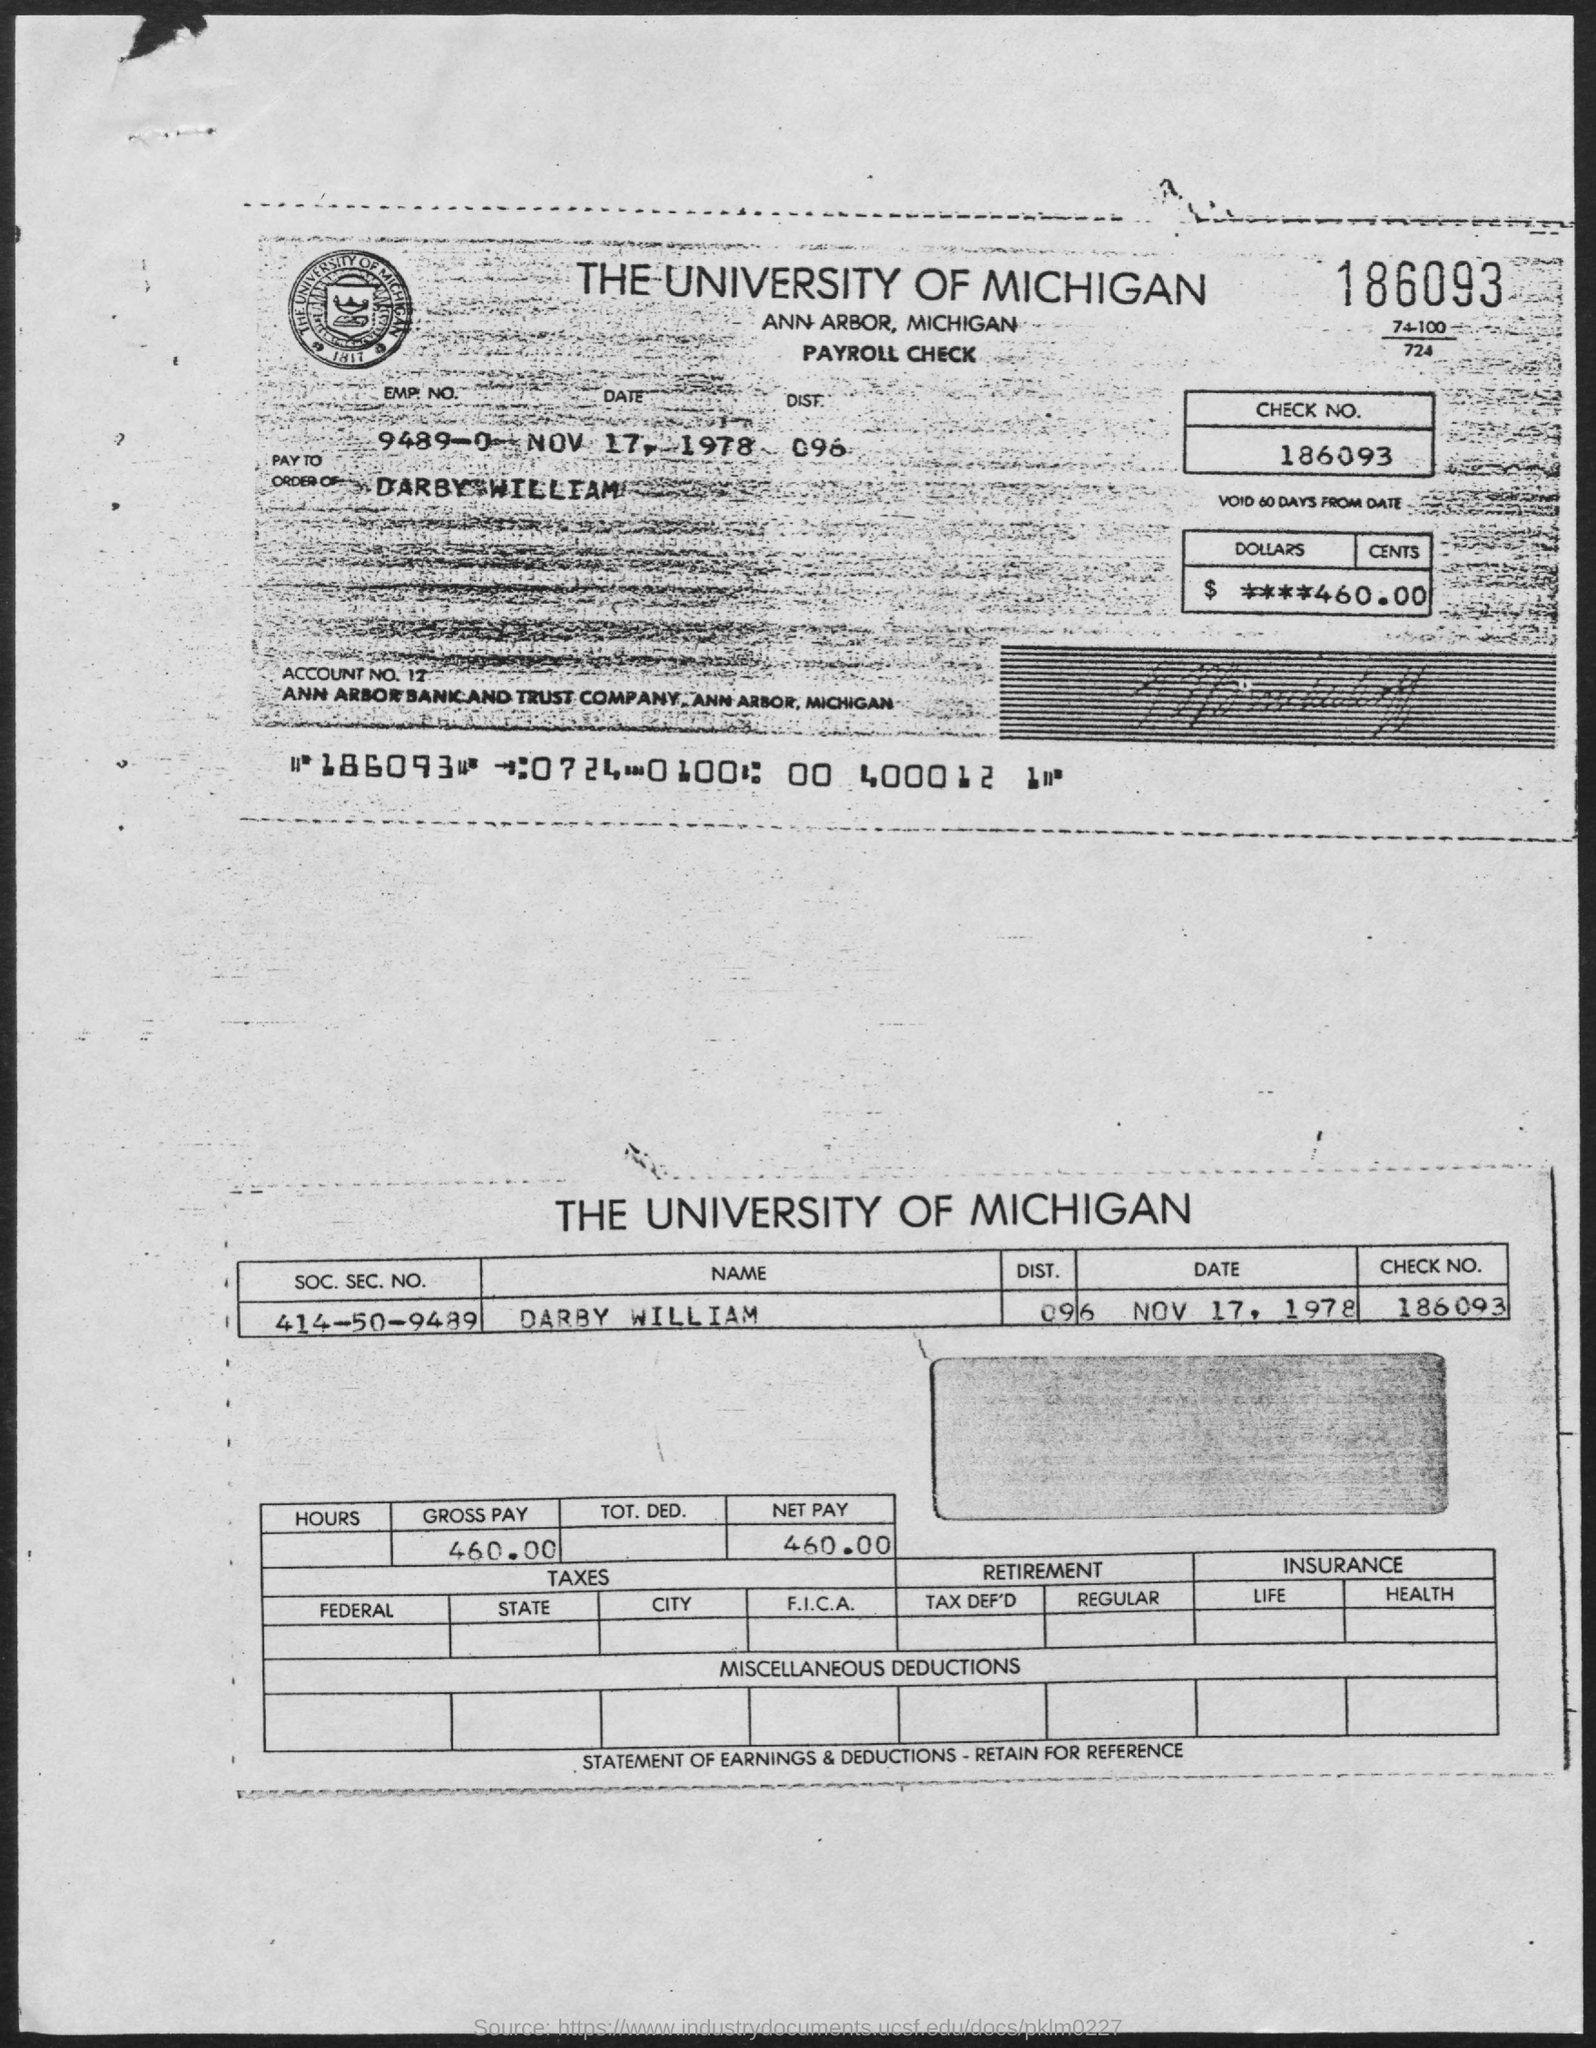What is the name of the university ?
Make the answer very short. The University of Michigan. How much is the amount in dollars and cents
Provide a succinct answer. $ ****460.00. Whose name is mentioned in the pay order to ?
Your answer should be very brief. Darby William. How much is the gross pay
Ensure brevity in your answer.  460.00. How much is the net pay ?
Offer a terse response. 460.00. 